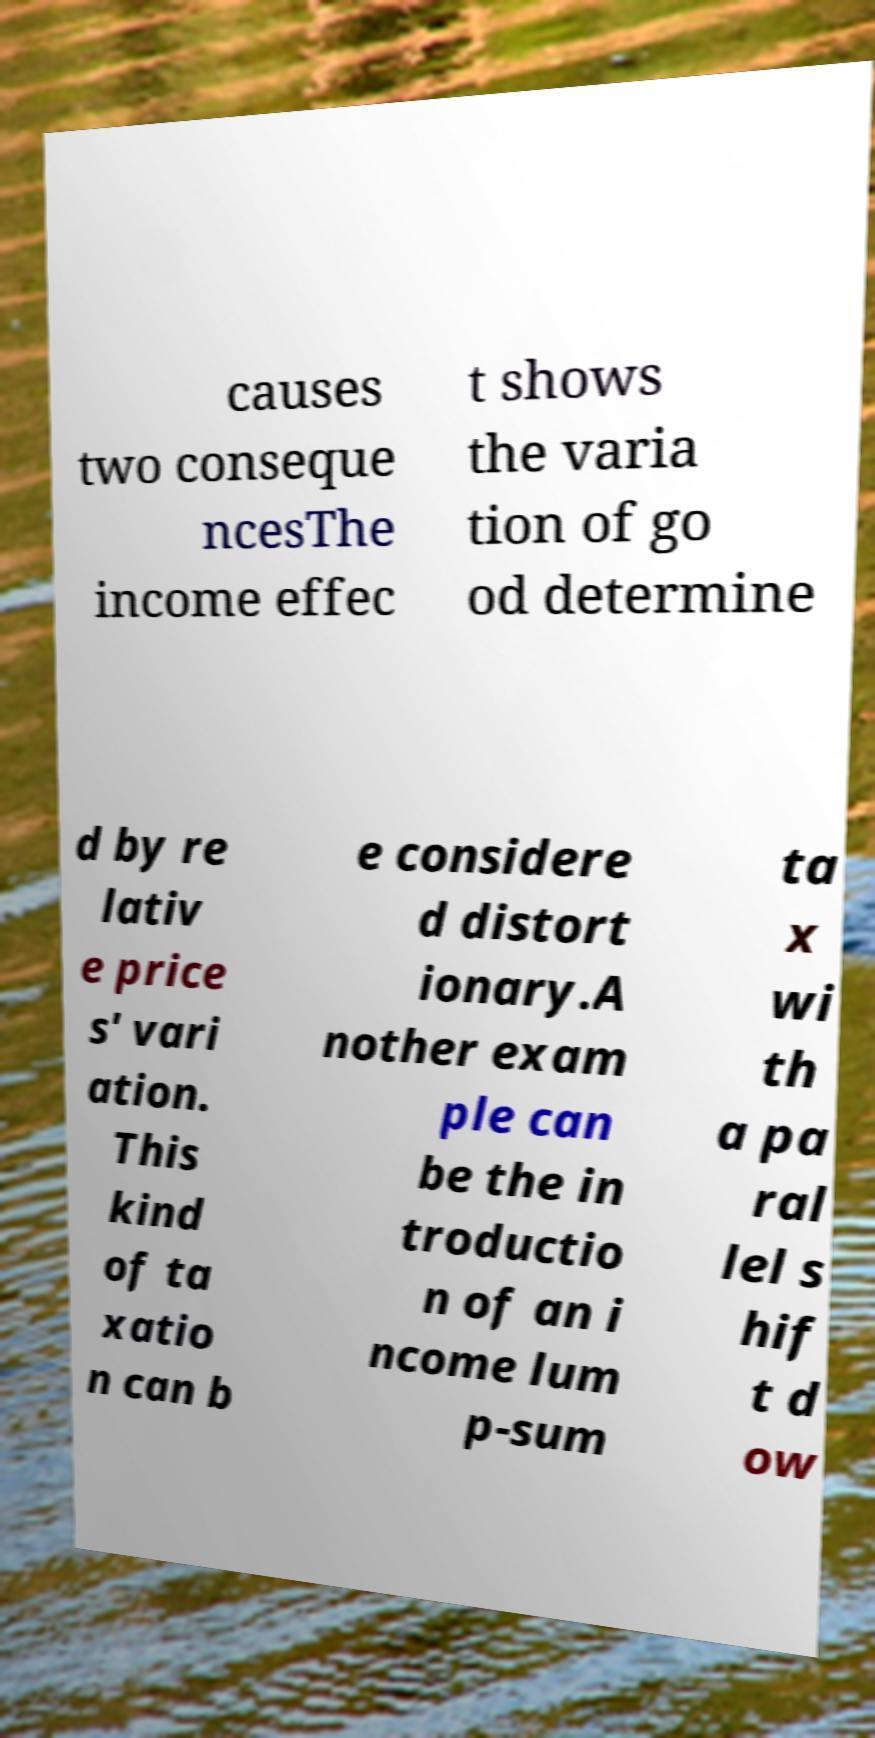There's text embedded in this image that I need extracted. Can you transcribe it verbatim? causes two conseque ncesThe income effec t shows the varia tion of go od determine d by re lativ e price s' vari ation. This kind of ta xatio n can b e considere d distort ionary.A nother exam ple can be the in troductio n of an i ncome lum p-sum ta x wi th a pa ral lel s hif t d ow 